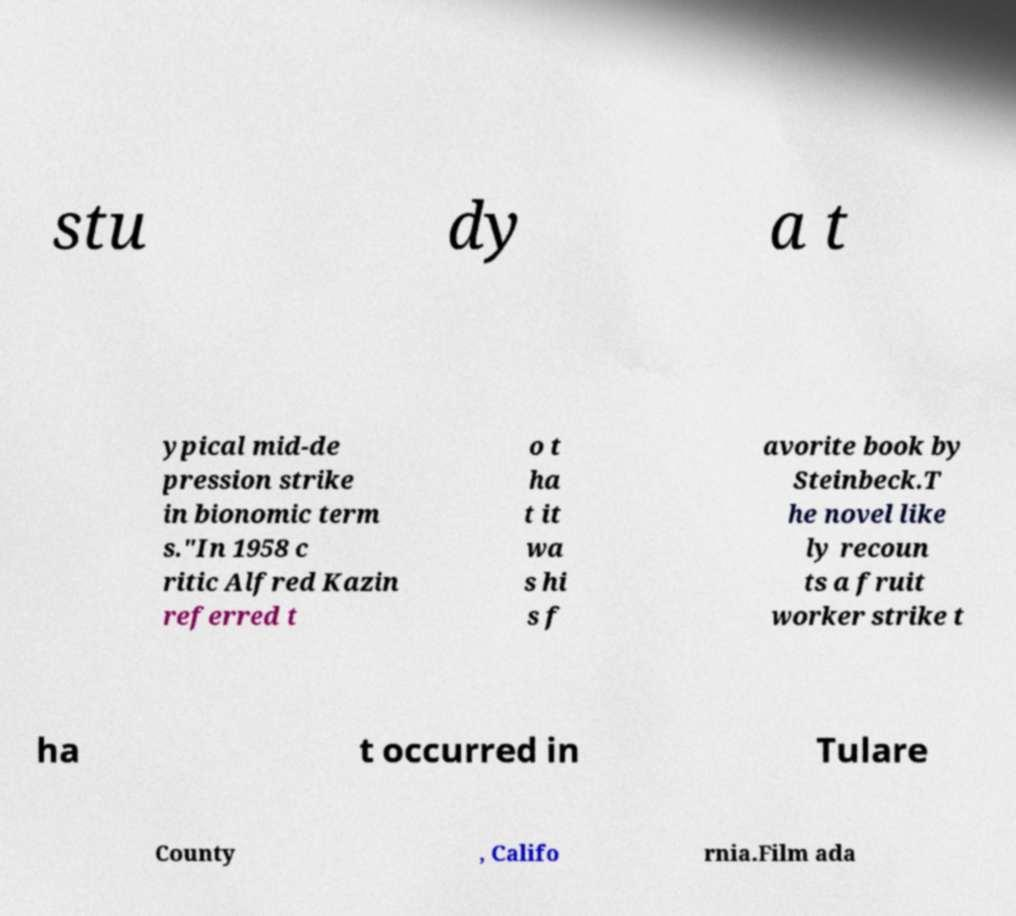For documentation purposes, I need the text within this image transcribed. Could you provide that? stu dy a t ypical mid-de pression strike in bionomic term s."In 1958 c ritic Alfred Kazin referred t o t ha t it wa s hi s f avorite book by Steinbeck.T he novel like ly recoun ts a fruit worker strike t ha t occurred in Tulare County , Califo rnia.Film ada 